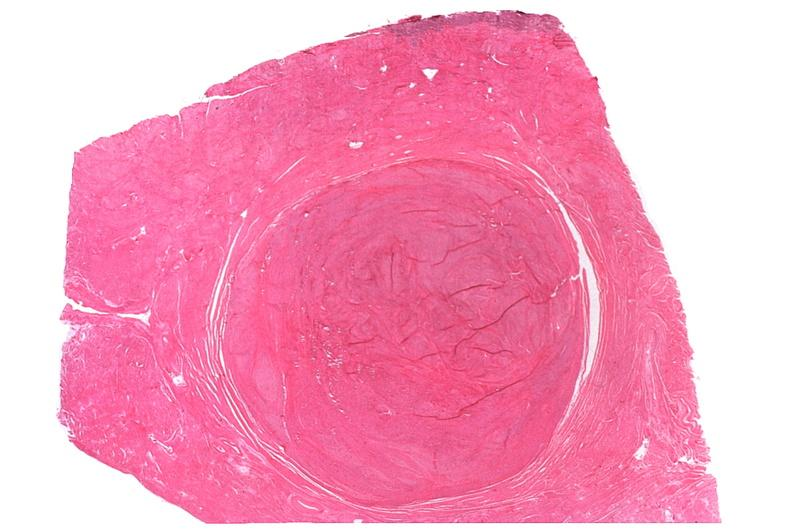where is this from?
Answer the question using a single word or phrase. Female reproductive system 